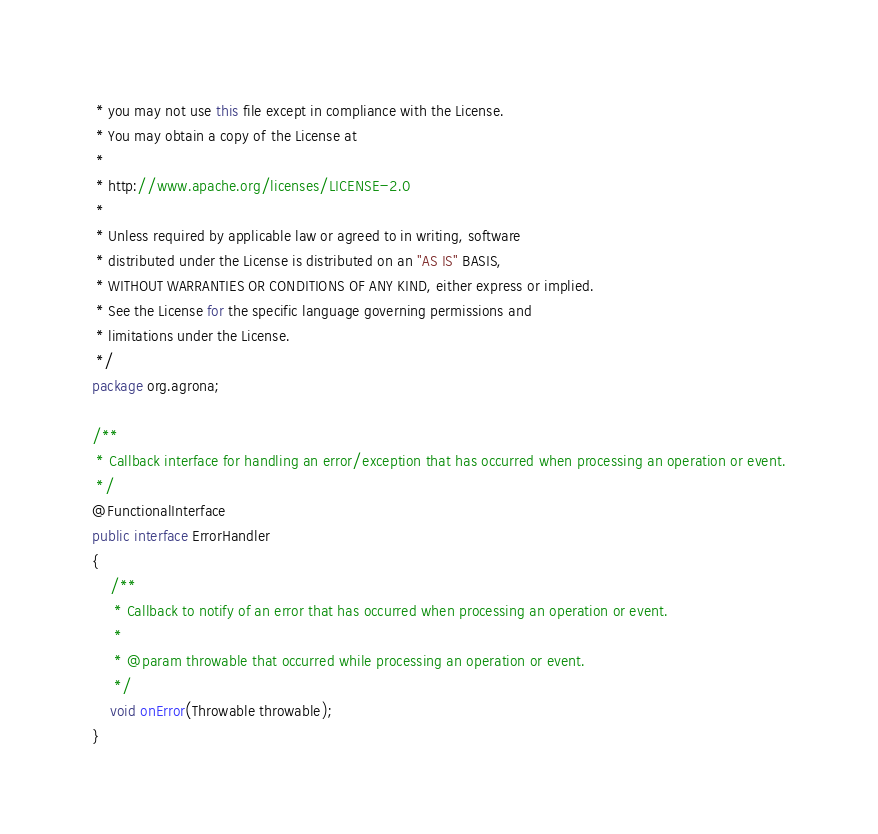Convert code to text. <code><loc_0><loc_0><loc_500><loc_500><_Java_> * you may not use this file except in compliance with the License.
 * You may obtain a copy of the License at
 *
 * http://www.apache.org/licenses/LICENSE-2.0
 *
 * Unless required by applicable law or agreed to in writing, software
 * distributed under the License is distributed on an "AS IS" BASIS,
 * WITHOUT WARRANTIES OR CONDITIONS OF ANY KIND, either express or implied.
 * See the License for the specific language governing permissions and
 * limitations under the License.
 */
package org.agrona;

/**
 * Callback interface for handling an error/exception that has occurred when processing an operation or event.
 */
@FunctionalInterface
public interface ErrorHandler
{
    /**
     * Callback to notify of an error that has occurred when processing an operation or event.
     *
     * @param throwable that occurred while processing an operation or event.
     */
    void onError(Throwable throwable);
}
</code> 